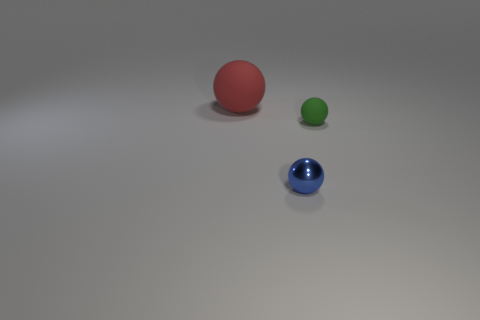Add 3 tiny yellow cylinders. How many objects exist? 6 Subtract all large red balls. How many balls are left? 2 Subtract all blue balls. How many balls are left? 2 Subtract 1 balls. How many balls are left? 2 Subtract all large balls. Subtract all small green objects. How many objects are left? 1 Add 1 rubber balls. How many rubber balls are left? 3 Add 3 green things. How many green things exist? 4 Subtract 0 yellow blocks. How many objects are left? 3 Subtract all brown balls. Subtract all green cylinders. How many balls are left? 3 Subtract all cyan cubes. How many cyan spheres are left? 0 